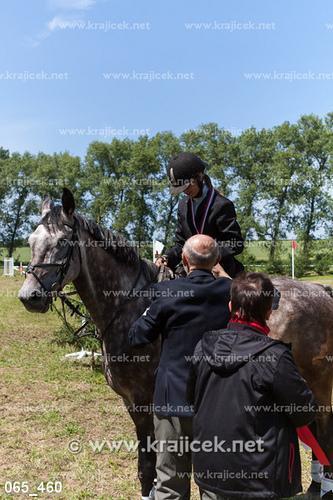How many people are in the photo?
Give a very brief answer. 3. 